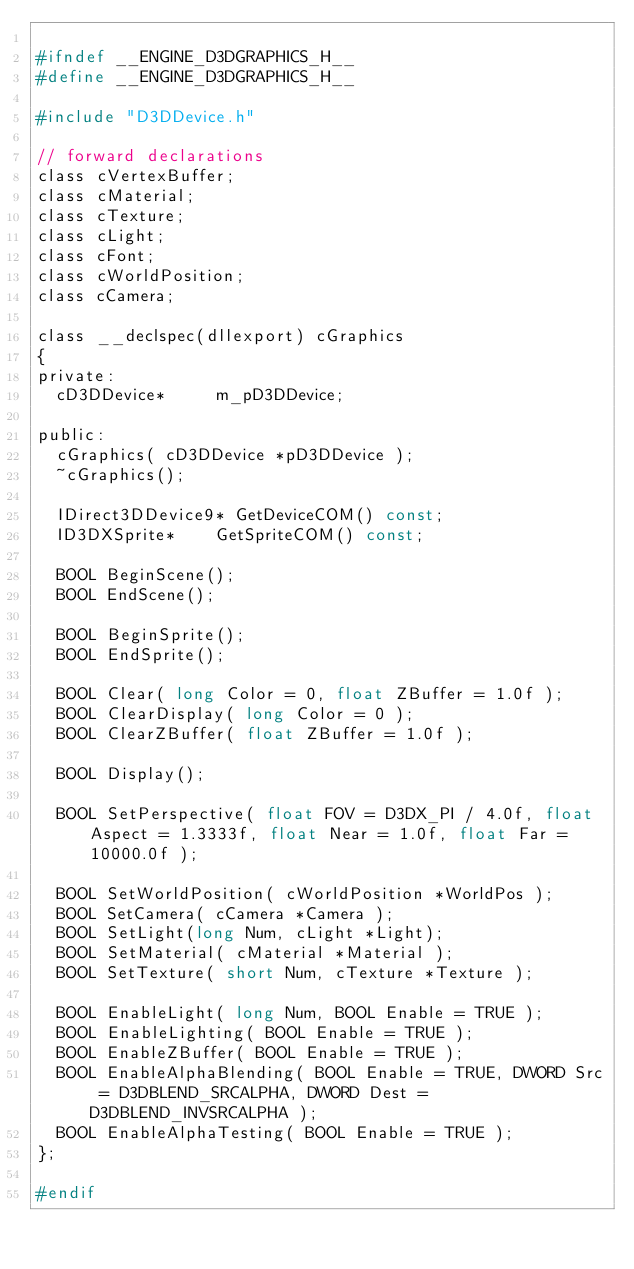Convert code to text. <code><loc_0><loc_0><loc_500><loc_500><_C_>
#ifndef __ENGINE_D3DGRAPHICS_H__
#define __ENGINE_D3DGRAPHICS_H__

#include "D3DDevice.h"

// forward declarations
class cVertexBuffer;
class cMaterial;
class cTexture;
class cLight;
class cFont;
class cWorldPosition;
class cCamera;

class __declspec(dllexport) cGraphics
{
private:
	cD3DDevice*			m_pD3DDevice;

public:
	cGraphics( cD3DDevice *pD3DDevice );
	~cGraphics();

	IDirect3DDevice9*	GetDeviceCOM() const;
	ID3DXSprite*		GetSpriteCOM() const;

	BOOL BeginScene();
	BOOL EndScene();

	BOOL BeginSprite();
	BOOL EndSprite();

	BOOL Clear( long Color = 0, float ZBuffer = 1.0f );
	BOOL ClearDisplay( long Color = 0 );
	BOOL ClearZBuffer( float ZBuffer = 1.0f );

	BOOL Display();

	BOOL SetPerspective( float FOV = D3DX_PI / 4.0f, float Aspect = 1.3333f, float Near = 1.0f, float Far = 10000.0f );

	BOOL SetWorldPosition( cWorldPosition *WorldPos );
	BOOL SetCamera( cCamera *Camera );
	BOOL SetLight(long Num, cLight *Light);
	BOOL SetMaterial( cMaterial *Material );
	BOOL SetTexture( short Num, cTexture *Texture );

	BOOL EnableLight( long Num, BOOL Enable = TRUE );
	BOOL EnableLighting( BOOL Enable = TRUE );
	BOOL EnableZBuffer( BOOL Enable = TRUE );
	BOOL EnableAlphaBlending( BOOL Enable = TRUE, DWORD Src = D3DBLEND_SRCALPHA, DWORD Dest = D3DBLEND_INVSRCALPHA );
	BOOL EnableAlphaTesting( BOOL Enable = TRUE );
};

#endif
</code> 